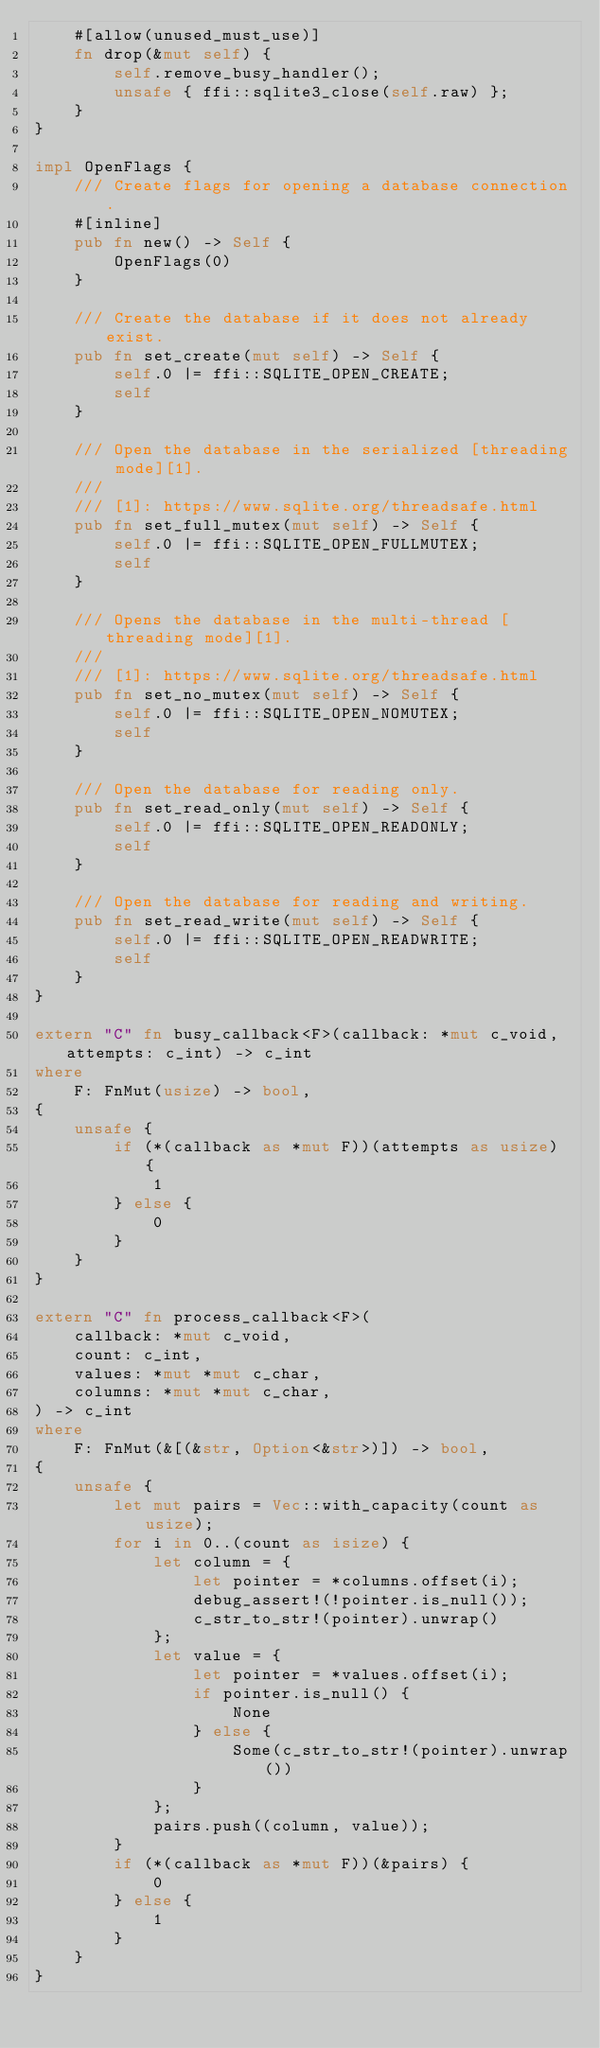<code> <loc_0><loc_0><loc_500><loc_500><_Rust_>    #[allow(unused_must_use)]
    fn drop(&mut self) {
        self.remove_busy_handler();
        unsafe { ffi::sqlite3_close(self.raw) };
    }
}

impl OpenFlags {
    /// Create flags for opening a database connection.
    #[inline]
    pub fn new() -> Self {
        OpenFlags(0)
    }

    /// Create the database if it does not already exist.
    pub fn set_create(mut self) -> Self {
        self.0 |= ffi::SQLITE_OPEN_CREATE;
        self
    }

    /// Open the database in the serialized [threading mode][1].
    ///
    /// [1]: https://www.sqlite.org/threadsafe.html
    pub fn set_full_mutex(mut self) -> Self {
        self.0 |= ffi::SQLITE_OPEN_FULLMUTEX;
        self
    }

    /// Opens the database in the multi-thread [threading mode][1].
    ///
    /// [1]: https://www.sqlite.org/threadsafe.html
    pub fn set_no_mutex(mut self) -> Self {
        self.0 |= ffi::SQLITE_OPEN_NOMUTEX;
        self
    }

    /// Open the database for reading only.
    pub fn set_read_only(mut self) -> Self {
        self.0 |= ffi::SQLITE_OPEN_READONLY;
        self
    }

    /// Open the database for reading and writing.
    pub fn set_read_write(mut self) -> Self {
        self.0 |= ffi::SQLITE_OPEN_READWRITE;
        self
    }
}

extern "C" fn busy_callback<F>(callback: *mut c_void, attempts: c_int) -> c_int
where
    F: FnMut(usize) -> bool,
{
    unsafe {
        if (*(callback as *mut F))(attempts as usize) {
            1
        } else {
            0
        }
    }
}

extern "C" fn process_callback<F>(
    callback: *mut c_void,
    count: c_int,
    values: *mut *mut c_char,
    columns: *mut *mut c_char,
) -> c_int
where
    F: FnMut(&[(&str, Option<&str>)]) -> bool,
{
    unsafe {
        let mut pairs = Vec::with_capacity(count as usize);
        for i in 0..(count as isize) {
            let column = {
                let pointer = *columns.offset(i);
                debug_assert!(!pointer.is_null());
                c_str_to_str!(pointer).unwrap()
            };
            let value = {
                let pointer = *values.offset(i);
                if pointer.is_null() {
                    None
                } else {
                    Some(c_str_to_str!(pointer).unwrap())
                }
            };
            pairs.push((column, value));
        }
        if (*(callback as *mut F))(&pairs) {
            0
        } else {
            1
        }
    }
}
</code> 